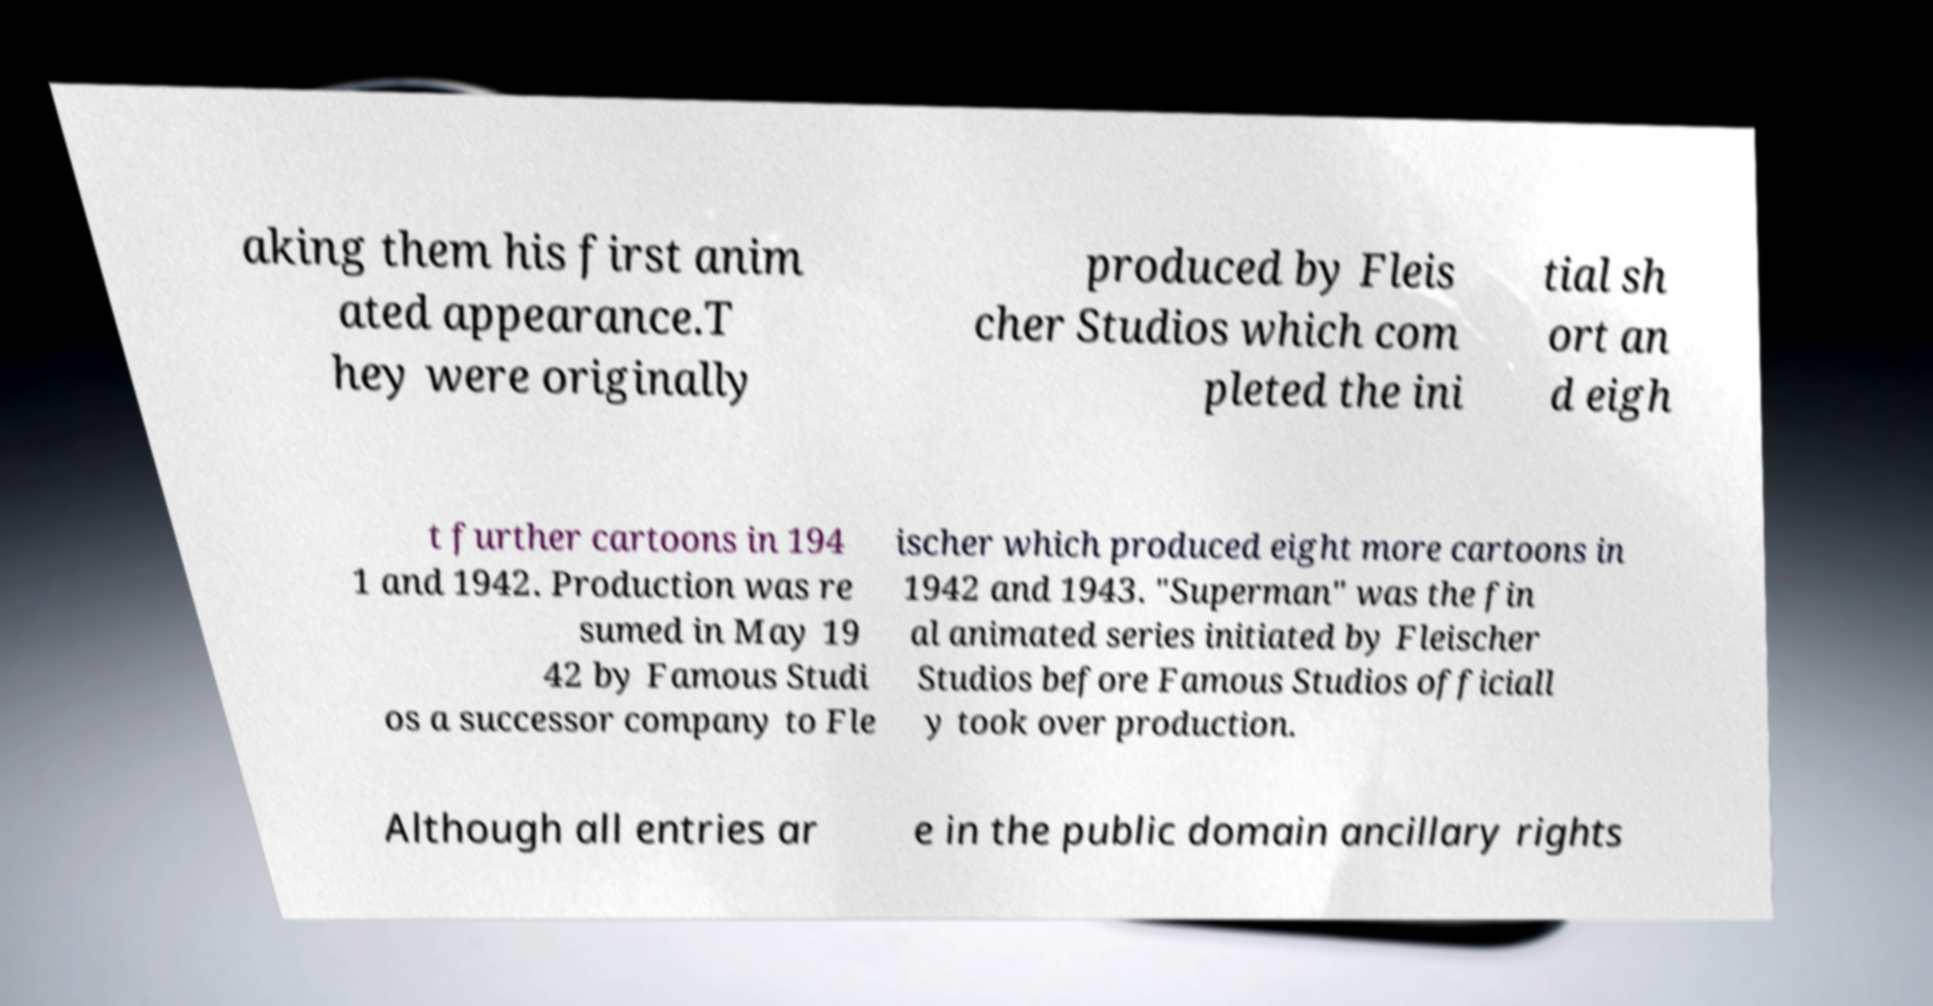Can you read and provide the text displayed in the image?This photo seems to have some interesting text. Can you extract and type it out for me? aking them his first anim ated appearance.T hey were originally produced by Fleis cher Studios which com pleted the ini tial sh ort an d eigh t further cartoons in 194 1 and 1942. Production was re sumed in May 19 42 by Famous Studi os a successor company to Fle ischer which produced eight more cartoons in 1942 and 1943. "Superman" was the fin al animated series initiated by Fleischer Studios before Famous Studios officiall y took over production. Although all entries ar e in the public domain ancillary rights 